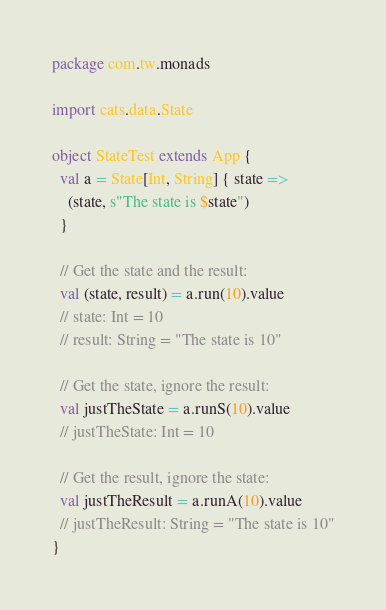<code> <loc_0><loc_0><loc_500><loc_500><_Scala_>package com.tw.monads

import cats.data.State

object StateTest extends App {
  val a = State[Int, String] { state =>
    (state, s"The state is $state")
  }

  // Get the state and the result:
  val (state, result) = a.run(10).value
  // state: Int = 10
  // result: String = "The state is 10"

  // Get the state, ignore the result:
  val justTheState = a.runS(10).value
  // justTheState: Int = 10

  // Get the result, ignore the state:
  val justTheResult = a.runA(10).value
  // justTheResult: String = "The state is 10"
}
</code> 